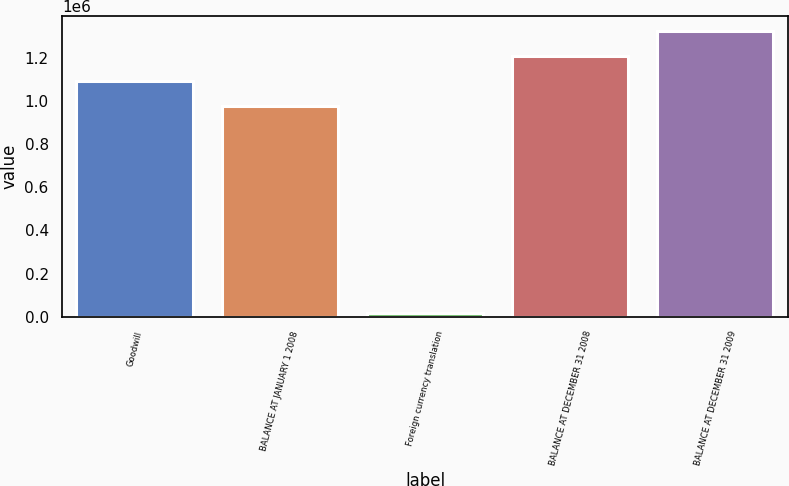Convert chart to OTSL. <chart><loc_0><loc_0><loc_500><loc_500><bar_chart><fcel>Goodwill<fcel>BALANCE AT JANUARY 1 2008<fcel>Foreign currency translation<fcel>BALANCE AT DECEMBER 31 2008<fcel>BALANCE AT DECEMBER 31 2009<nl><fcel>1.09308e+06<fcel>977019<fcel>19861<fcel>1.20914e+06<fcel>1.32519e+06<nl></chart> 